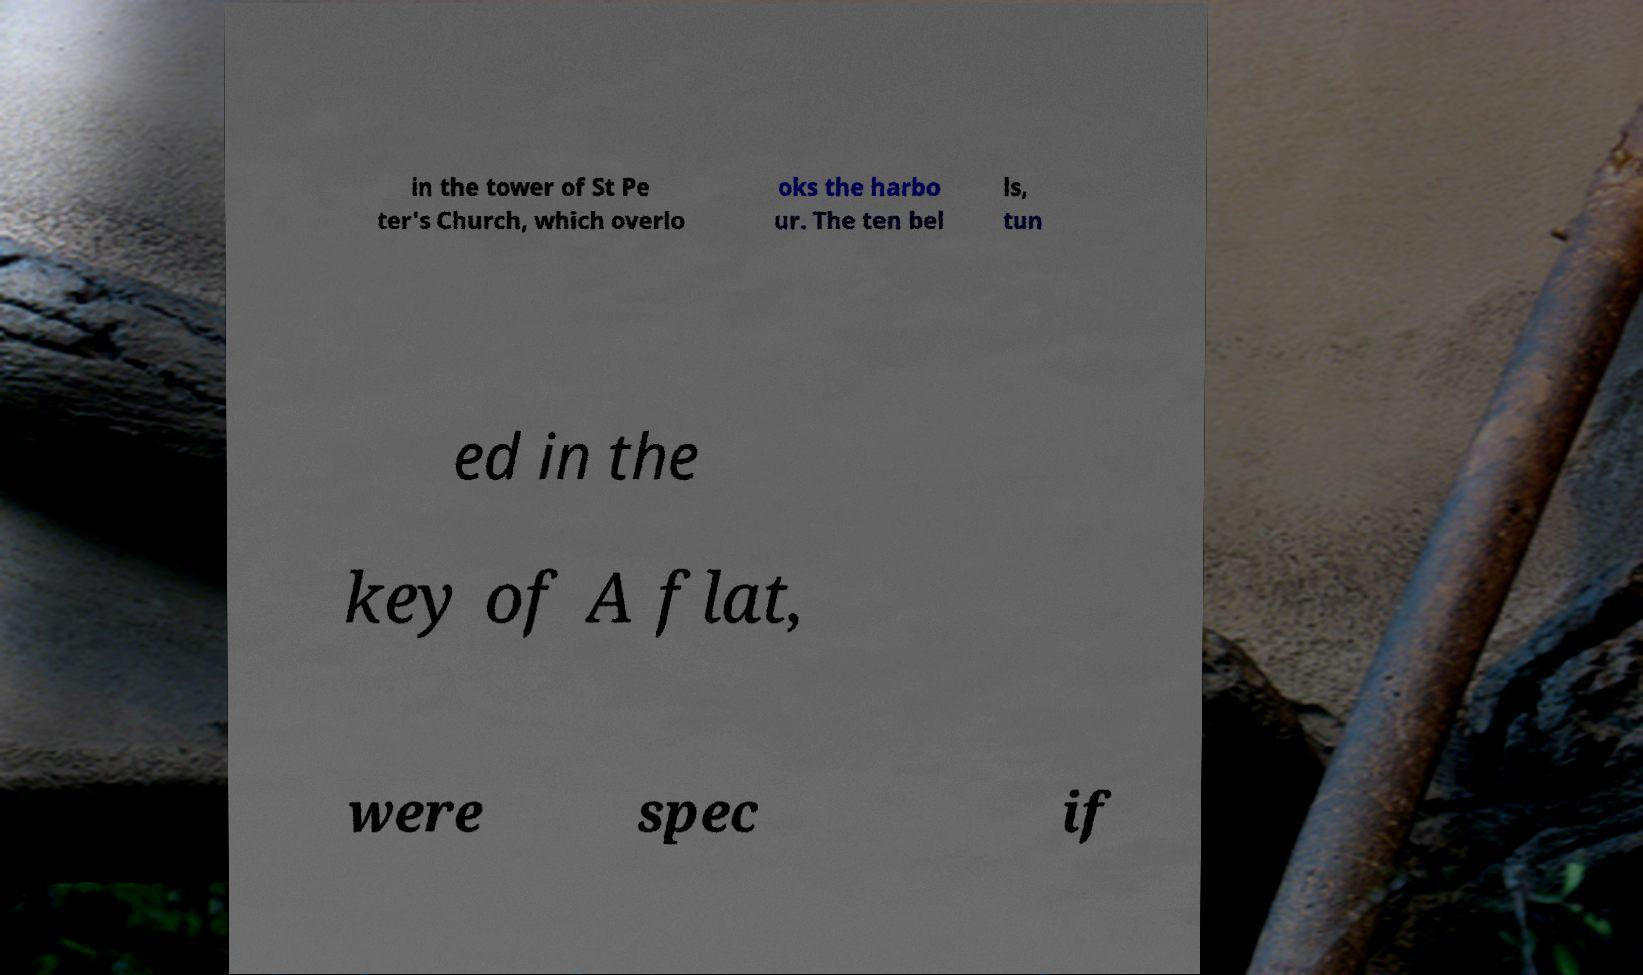Please read and relay the text visible in this image. What does it say? in the tower of St Pe ter's Church, which overlo oks the harbo ur. The ten bel ls, tun ed in the key of A flat, were spec if 